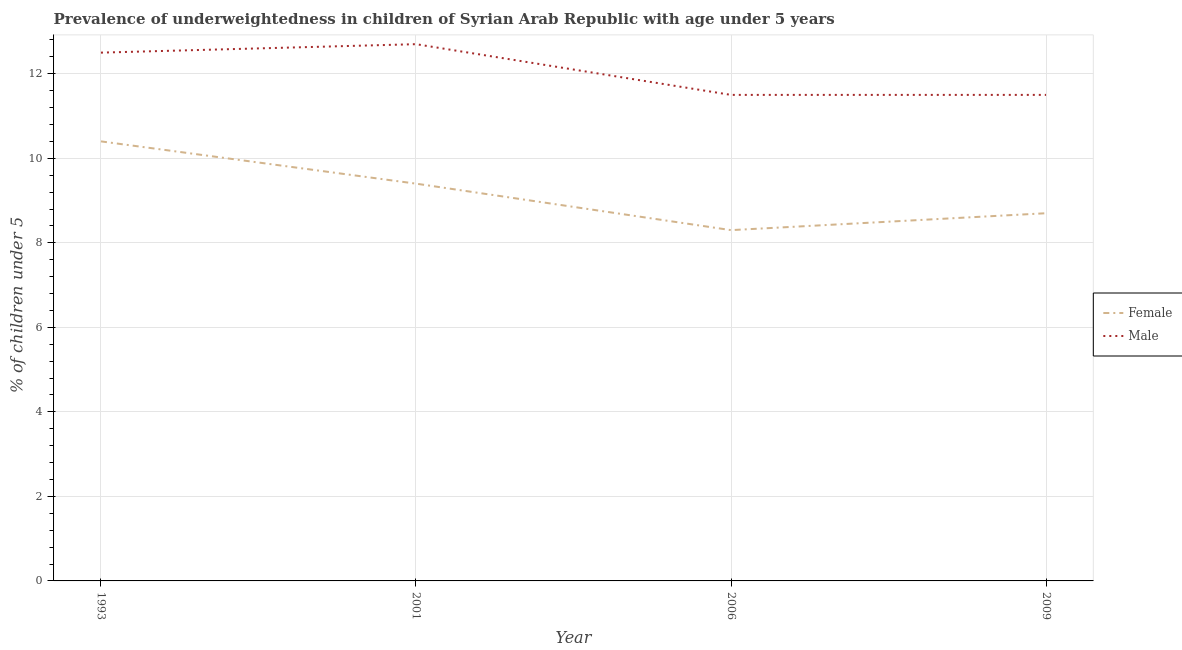Is the number of lines equal to the number of legend labels?
Your response must be concise. Yes. What is the percentage of underweighted male children in 2009?
Your answer should be compact. 11.5. Across all years, what is the maximum percentage of underweighted female children?
Provide a short and direct response. 10.4. In which year was the percentage of underweighted female children maximum?
Ensure brevity in your answer.  1993. In which year was the percentage of underweighted male children minimum?
Provide a short and direct response. 2006. What is the total percentage of underweighted female children in the graph?
Make the answer very short. 36.8. What is the difference between the percentage of underweighted female children in 1993 and that in 2009?
Give a very brief answer. 1.7. What is the difference between the percentage of underweighted female children in 2009 and the percentage of underweighted male children in 2001?
Ensure brevity in your answer.  -4. What is the average percentage of underweighted female children per year?
Offer a terse response. 9.2. In the year 2009, what is the difference between the percentage of underweighted male children and percentage of underweighted female children?
Offer a terse response. 2.8. What is the ratio of the percentage of underweighted male children in 1993 to that in 2006?
Give a very brief answer. 1.09. Is the percentage of underweighted female children in 2006 less than that in 2009?
Provide a short and direct response. Yes. What is the difference between the highest and the second highest percentage of underweighted male children?
Make the answer very short. 0.2. What is the difference between the highest and the lowest percentage of underweighted male children?
Keep it short and to the point. 1.2. Is the sum of the percentage of underweighted female children in 2001 and 2006 greater than the maximum percentage of underweighted male children across all years?
Offer a very short reply. Yes. Does the percentage of underweighted male children monotonically increase over the years?
Make the answer very short. No. Is the percentage of underweighted male children strictly greater than the percentage of underweighted female children over the years?
Offer a very short reply. Yes. How many years are there in the graph?
Provide a short and direct response. 4. Does the graph contain grids?
Provide a succinct answer. Yes. Where does the legend appear in the graph?
Your answer should be compact. Center right. How many legend labels are there?
Keep it short and to the point. 2. How are the legend labels stacked?
Make the answer very short. Vertical. What is the title of the graph?
Ensure brevity in your answer.  Prevalence of underweightedness in children of Syrian Arab Republic with age under 5 years. What is the label or title of the Y-axis?
Provide a succinct answer.  % of children under 5. What is the  % of children under 5 of Female in 1993?
Ensure brevity in your answer.  10.4. What is the  % of children under 5 of Male in 1993?
Your answer should be very brief. 12.5. What is the  % of children under 5 of Female in 2001?
Offer a very short reply. 9.4. What is the  % of children under 5 in Male in 2001?
Provide a short and direct response. 12.7. What is the  % of children under 5 of Female in 2006?
Offer a terse response. 8.3. What is the  % of children under 5 of Male in 2006?
Ensure brevity in your answer.  11.5. What is the  % of children under 5 in Female in 2009?
Provide a short and direct response. 8.7. What is the  % of children under 5 in Male in 2009?
Ensure brevity in your answer.  11.5. Across all years, what is the maximum  % of children under 5 of Female?
Keep it short and to the point. 10.4. Across all years, what is the maximum  % of children under 5 of Male?
Keep it short and to the point. 12.7. Across all years, what is the minimum  % of children under 5 of Female?
Ensure brevity in your answer.  8.3. Across all years, what is the minimum  % of children under 5 in Male?
Ensure brevity in your answer.  11.5. What is the total  % of children under 5 of Female in the graph?
Provide a succinct answer. 36.8. What is the total  % of children under 5 in Male in the graph?
Make the answer very short. 48.2. What is the difference between the  % of children under 5 of Female in 1993 and that in 2001?
Give a very brief answer. 1. What is the difference between the  % of children under 5 of Male in 1993 and that in 2006?
Provide a succinct answer. 1. What is the difference between the  % of children under 5 of Female in 1993 and that in 2009?
Keep it short and to the point. 1.7. What is the difference between the  % of children under 5 in Female in 2001 and that in 2006?
Your answer should be very brief. 1.1. What is the difference between the  % of children under 5 in Male in 2001 and that in 2006?
Provide a short and direct response. 1.2. What is the difference between the  % of children under 5 in Female in 2001 and that in 2009?
Provide a succinct answer. 0.7. What is the difference between the  % of children under 5 in Male in 2001 and that in 2009?
Provide a short and direct response. 1.2. What is the difference between the  % of children under 5 of Female in 1993 and the  % of children under 5 of Male in 2001?
Provide a short and direct response. -2.3. What is the difference between the  % of children under 5 of Female in 1993 and the  % of children under 5 of Male in 2006?
Keep it short and to the point. -1.1. What is the difference between the  % of children under 5 of Female in 1993 and the  % of children under 5 of Male in 2009?
Ensure brevity in your answer.  -1.1. What is the difference between the  % of children under 5 in Female in 2001 and the  % of children under 5 in Male in 2006?
Give a very brief answer. -2.1. What is the difference between the  % of children under 5 in Female in 2006 and the  % of children under 5 in Male in 2009?
Your answer should be very brief. -3.2. What is the average  % of children under 5 in Male per year?
Provide a short and direct response. 12.05. In the year 1993, what is the difference between the  % of children under 5 in Female and  % of children under 5 in Male?
Your answer should be very brief. -2.1. In the year 2001, what is the difference between the  % of children under 5 in Female and  % of children under 5 in Male?
Provide a short and direct response. -3.3. In the year 2006, what is the difference between the  % of children under 5 in Female and  % of children under 5 in Male?
Provide a short and direct response. -3.2. What is the ratio of the  % of children under 5 of Female in 1993 to that in 2001?
Make the answer very short. 1.11. What is the ratio of the  % of children under 5 in Male in 1993 to that in 2001?
Make the answer very short. 0.98. What is the ratio of the  % of children under 5 in Female in 1993 to that in 2006?
Provide a succinct answer. 1.25. What is the ratio of the  % of children under 5 in Male in 1993 to that in 2006?
Provide a succinct answer. 1.09. What is the ratio of the  % of children under 5 of Female in 1993 to that in 2009?
Make the answer very short. 1.2. What is the ratio of the  % of children under 5 in Male in 1993 to that in 2009?
Make the answer very short. 1.09. What is the ratio of the  % of children under 5 of Female in 2001 to that in 2006?
Provide a succinct answer. 1.13. What is the ratio of the  % of children under 5 in Male in 2001 to that in 2006?
Make the answer very short. 1.1. What is the ratio of the  % of children under 5 in Female in 2001 to that in 2009?
Provide a short and direct response. 1.08. What is the ratio of the  % of children under 5 in Male in 2001 to that in 2009?
Your answer should be very brief. 1.1. What is the ratio of the  % of children under 5 in Female in 2006 to that in 2009?
Offer a terse response. 0.95. What is the difference between the highest and the second highest  % of children under 5 of Female?
Give a very brief answer. 1. What is the difference between the highest and the second highest  % of children under 5 in Male?
Make the answer very short. 0.2. What is the difference between the highest and the lowest  % of children under 5 in Female?
Your answer should be very brief. 2.1. 